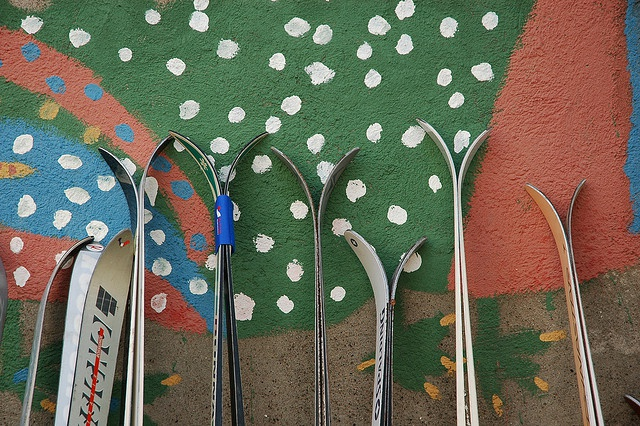Describe the objects in this image and their specific colors. I can see skis in darkgreen, black, gray, and darkgray tones, skis in darkgreen, lightgray, and gray tones, skis in darkgreen, black, lightgray, darkgray, and gray tones, skis in darkgreen, salmon, lightgray, maroon, and tan tones, and skis in darkgreen, lightgray, darkgray, and gray tones in this image. 